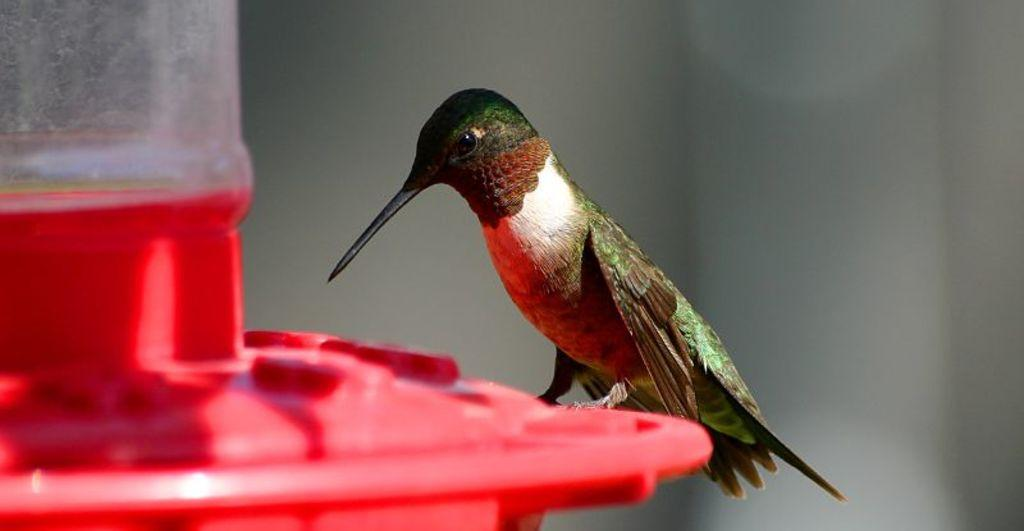What type of animal is depicted in the image? There is a bird represented in the image. Can you see any steam coming from the bird's beak in the image? There is no steam present in the image, as it features a bird and no other elements that would produce steam. 